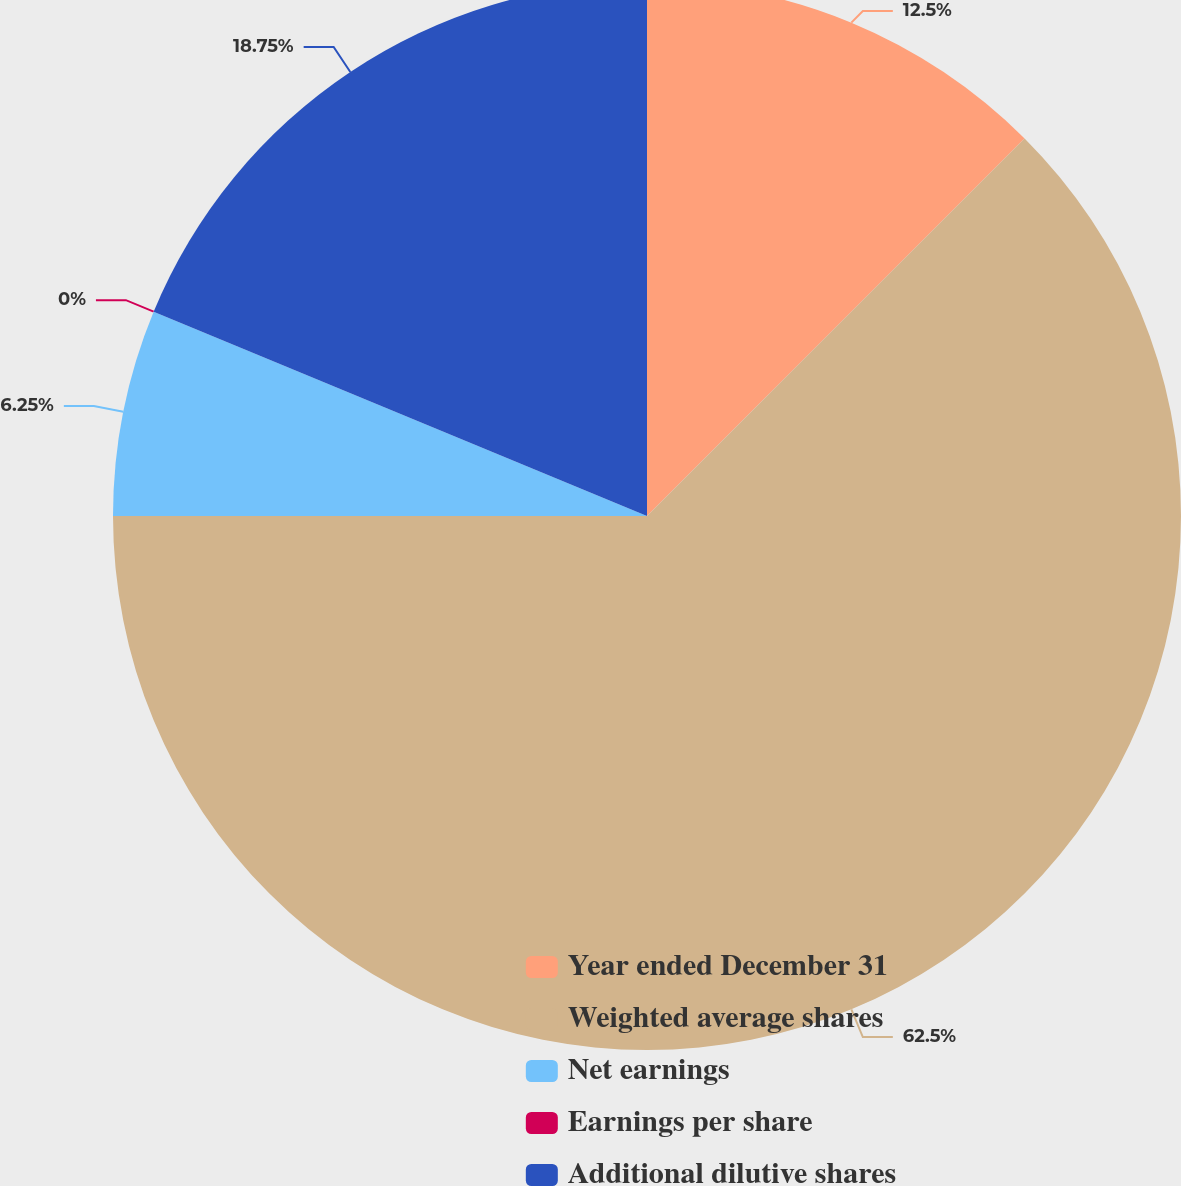Convert chart to OTSL. <chart><loc_0><loc_0><loc_500><loc_500><pie_chart><fcel>Year ended December 31<fcel>Weighted average shares<fcel>Net earnings<fcel>Earnings per share<fcel>Additional dilutive shares<nl><fcel>12.5%<fcel>62.5%<fcel>6.25%<fcel>0.0%<fcel>18.75%<nl></chart> 